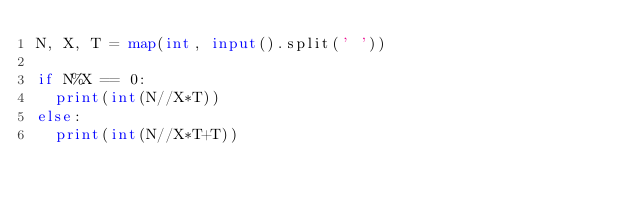Convert code to text. <code><loc_0><loc_0><loc_500><loc_500><_Python_>N, X, T = map(int, input().split(' '))

if N%X == 0:
  print(int(N//X*T))
else:
  print(int(N//X*T+T))</code> 